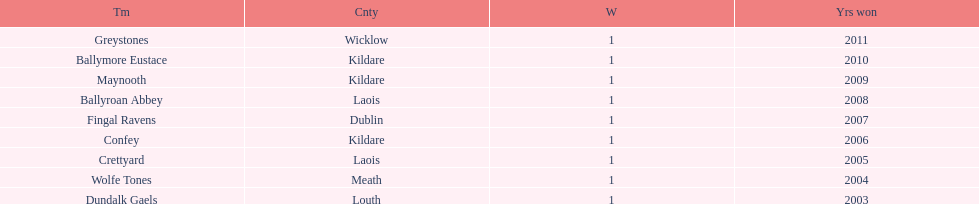Which team won previous to crettyard? Wolfe Tones. 